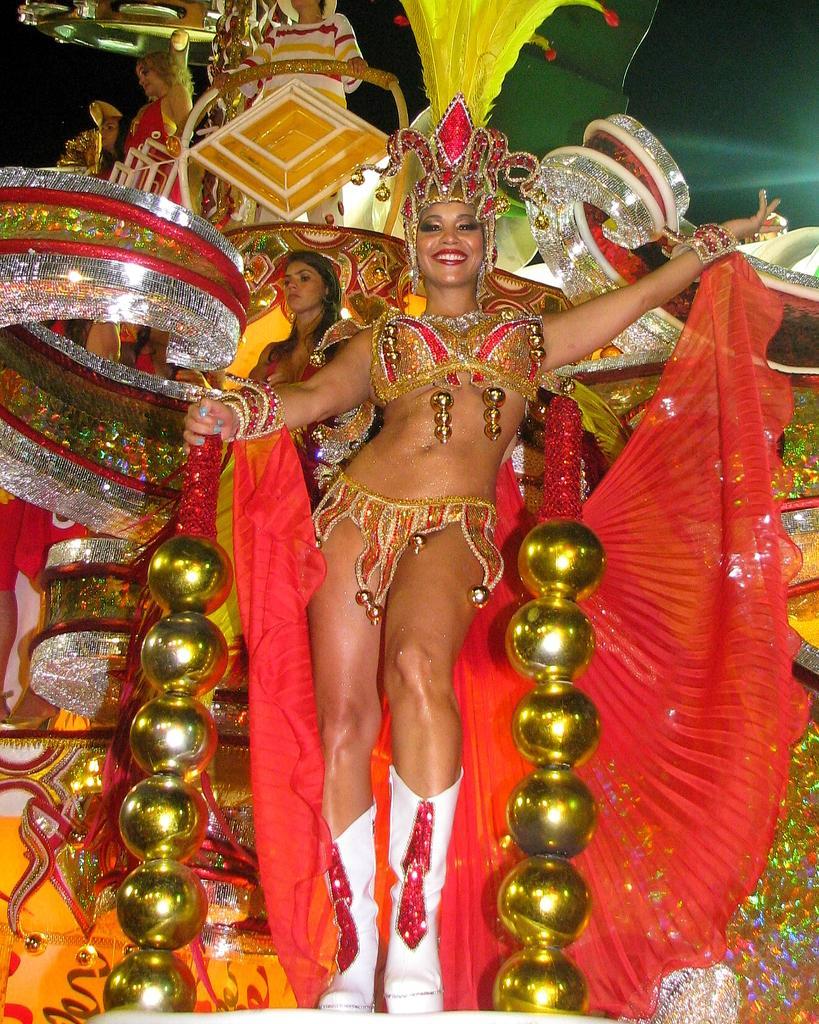Describe this image in one or two sentences. In this picture we can see a woman in the fancy dress is holding an object. Behind the woman there are some people standing on an object and behind the people there is a dark background. 